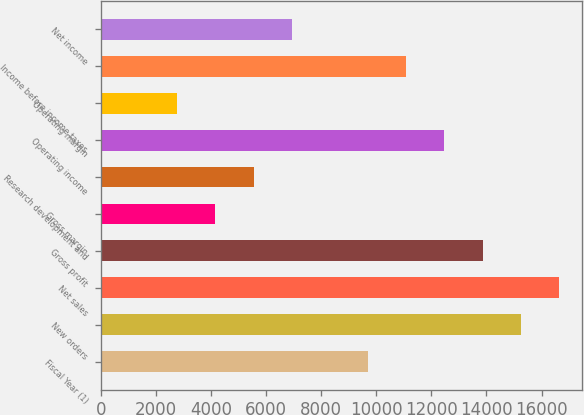Convert chart to OTSL. <chart><loc_0><loc_0><loc_500><loc_500><bar_chart><fcel>Fiscal Year (1)<fcel>New orders<fcel>Net sales<fcel>Gross profit<fcel>Gross margin<fcel>Research development and<fcel>Operating income<fcel>Operating margin<fcel>Income before income taxes<fcel>Net income<nl><fcel>9702.8<fcel>15247.1<fcel>16633.2<fcel>13861<fcel>4158.52<fcel>5544.59<fcel>12474.9<fcel>2772.45<fcel>11088.9<fcel>6930.66<nl></chart> 